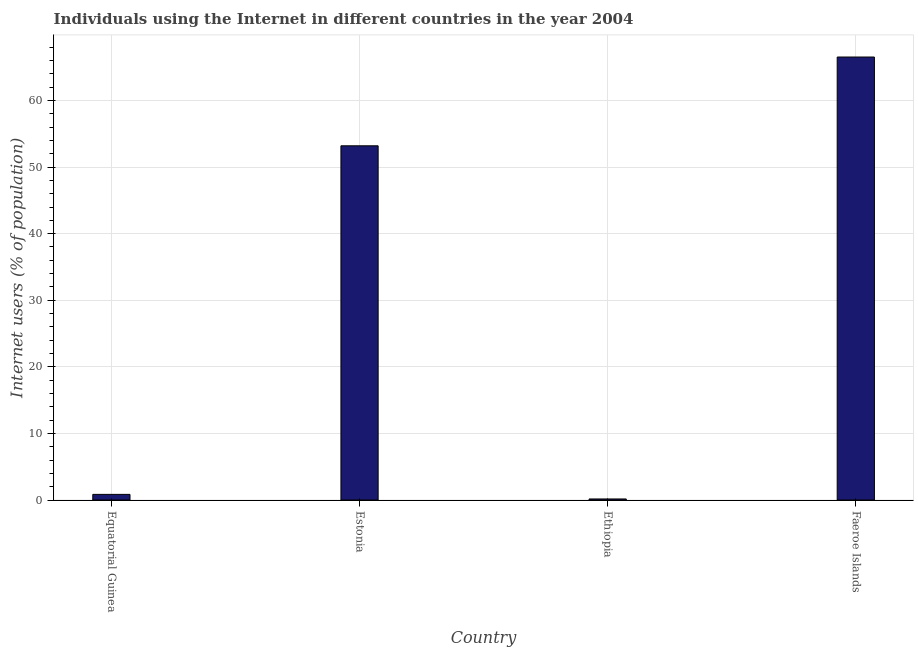Does the graph contain any zero values?
Your response must be concise. No. What is the title of the graph?
Offer a very short reply. Individuals using the Internet in different countries in the year 2004. What is the label or title of the X-axis?
Your answer should be very brief. Country. What is the label or title of the Y-axis?
Your answer should be compact. Internet users (% of population). What is the number of internet users in Ethiopia?
Provide a short and direct response. 0.16. Across all countries, what is the maximum number of internet users?
Offer a terse response. 66.53. Across all countries, what is the minimum number of internet users?
Provide a short and direct response. 0.16. In which country was the number of internet users maximum?
Give a very brief answer. Faeroe Islands. In which country was the number of internet users minimum?
Give a very brief answer. Ethiopia. What is the sum of the number of internet users?
Provide a short and direct response. 120.73. What is the difference between the number of internet users in Ethiopia and Faeroe Islands?
Provide a succinct answer. -66.38. What is the average number of internet users per country?
Give a very brief answer. 30.18. What is the median number of internet users?
Keep it short and to the point. 27.02. What is the ratio of the number of internet users in Equatorial Guinea to that in Ethiopia?
Your response must be concise. 5.43. Is the difference between the number of internet users in Equatorial Guinea and Faeroe Islands greater than the difference between any two countries?
Offer a terse response. No. What is the difference between the highest and the second highest number of internet users?
Make the answer very short. 13.33. Is the sum of the number of internet users in Equatorial Guinea and Estonia greater than the maximum number of internet users across all countries?
Your answer should be compact. No. What is the difference between the highest and the lowest number of internet users?
Provide a succinct answer. 66.38. How many countries are there in the graph?
Provide a succinct answer. 4. What is the difference between two consecutive major ticks on the Y-axis?
Make the answer very short. 10. What is the Internet users (% of population) in Equatorial Guinea?
Your answer should be compact. 0.84. What is the Internet users (% of population) of Estonia?
Your answer should be very brief. 53.2. What is the Internet users (% of population) in Ethiopia?
Make the answer very short. 0.16. What is the Internet users (% of population) of Faeroe Islands?
Ensure brevity in your answer.  66.53. What is the difference between the Internet users (% of population) in Equatorial Guinea and Estonia?
Keep it short and to the point. -52.36. What is the difference between the Internet users (% of population) in Equatorial Guinea and Ethiopia?
Offer a terse response. 0.69. What is the difference between the Internet users (% of population) in Equatorial Guinea and Faeroe Islands?
Provide a short and direct response. -65.69. What is the difference between the Internet users (% of population) in Estonia and Ethiopia?
Keep it short and to the point. 53.04. What is the difference between the Internet users (% of population) in Estonia and Faeroe Islands?
Provide a short and direct response. -13.33. What is the difference between the Internet users (% of population) in Ethiopia and Faeroe Islands?
Provide a succinct answer. -66.38. What is the ratio of the Internet users (% of population) in Equatorial Guinea to that in Estonia?
Ensure brevity in your answer.  0.02. What is the ratio of the Internet users (% of population) in Equatorial Guinea to that in Ethiopia?
Your answer should be compact. 5.43. What is the ratio of the Internet users (% of population) in Equatorial Guinea to that in Faeroe Islands?
Ensure brevity in your answer.  0.01. What is the ratio of the Internet users (% of population) in Estonia to that in Ethiopia?
Your response must be concise. 342.49. What is the ratio of the Internet users (% of population) in Ethiopia to that in Faeroe Islands?
Make the answer very short. 0. 